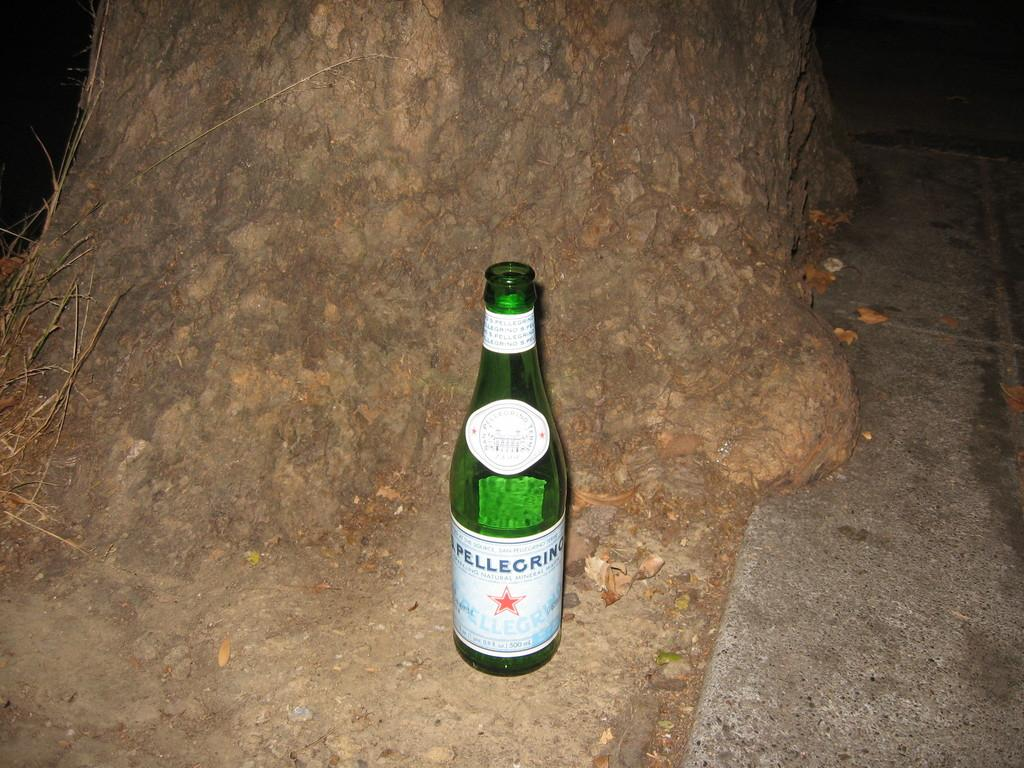<image>
Create a compact narrative representing the image presented. the word pellegrino that is on a bottle 